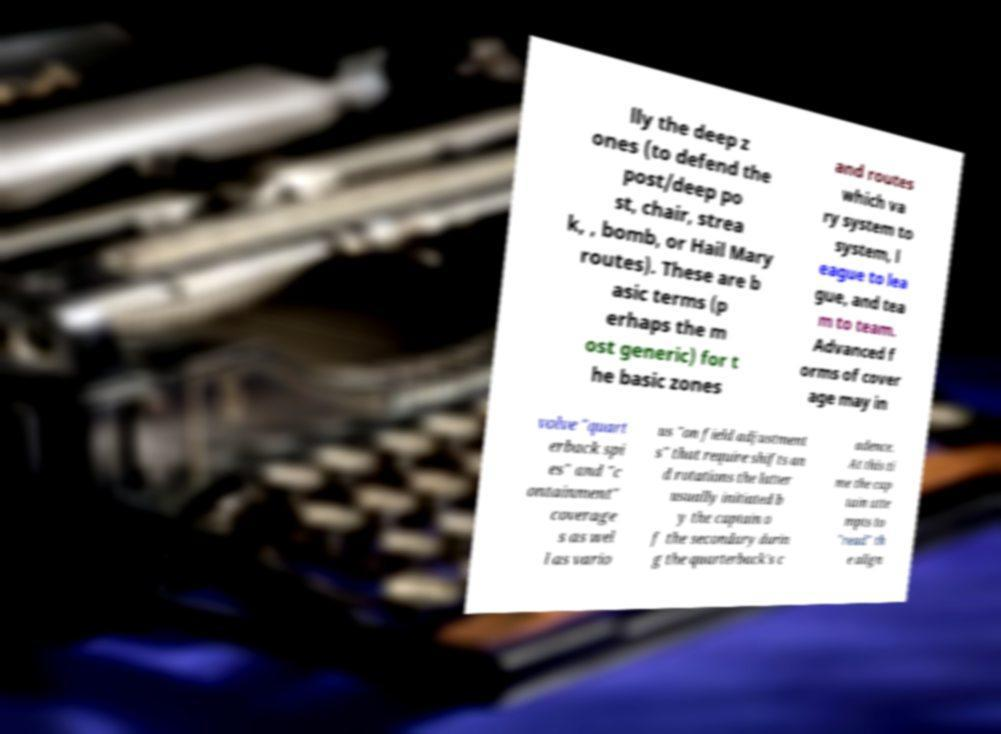There's text embedded in this image that I need extracted. Can you transcribe it verbatim? lly the deep z ones (to defend the post/deep po st, chair, strea k, , bomb, or Hail Mary routes). These are b asic terms (p erhaps the m ost generic) for t he basic zones and routes which va ry system to system, l eague to lea gue, and tea m to team. Advanced f orms of cover age may in volve "quart erback spi es" and "c ontainment" coverage s as wel l as vario us "on field adjustment s" that require shifts an d rotations the latter usually initiated b y the captain o f the secondary durin g the quarterback's c adence. At this ti me the cap tain atte mpts to "read" th e align 